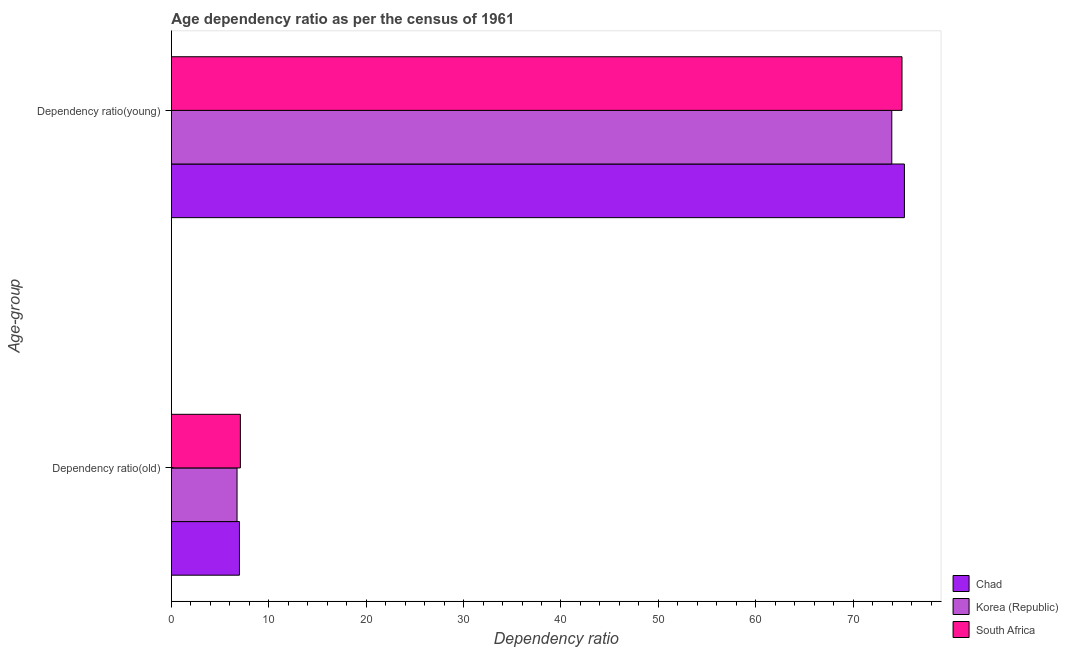Are the number of bars per tick equal to the number of legend labels?
Provide a short and direct response. Yes. How many bars are there on the 2nd tick from the top?
Make the answer very short. 3. What is the label of the 1st group of bars from the top?
Provide a succinct answer. Dependency ratio(young). What is the age dependency ratio(young) in South Africa?
Provide a short and direct response. 75.02. Across all countries, what is the maximum age dependency ratio(young)?
Provide a short and direct response. 75.27. Across all countries, what is the minimum age dependency ratio(old)?
Ensure brevity in your answer.  6.74. In which country was the age dependency ratio(young) maximum?
Offer a terse response. Chad. In which country was the age dependency ratio(old) minimum?
Give a very brief answer. Korea (Republic). What is the total age dependency ratio(young) in the graph?
Offer a very short reply. 224.25. What is the difference between the age dependency ratio(old) in South Africa and that in Korea (Republic)?
Offer a terse response. 0.34. What is the difference between the age dependency ratio(young) in South Africa and the age dependency ratio(old) in Korea (Republic)?
Provide a short and direct response. 68.27. What is the average age dependency ratio(young) per country?
Make the answer very short. 74.75. What is the difference between the age dependency ratio(young) and age dependency ratio(old) in Korea (Republic)?
Your answer should be very brief. 67.23. What is the ratio of the age dependency ratio(old) in Chad to that in South Africa?
Offer a terse response. 0.99. What does the 1st bar from the top in Dependency ratio(old) represents?
Provide a short and direct response. South Africa. What does the 3rd bar from the bottom in Dependency ratio(young) represents?
Offer a terse response. South Africa. Are all the bars in the graph horizontal?
Offer a terse response. Yes. How many countries are there in the graph?
Your answer should be very brief. 3. Are the values on the major ticks of X-axis written in scientific E-notation?
Provide a succinct answer. No. Does the graph contain grids?
Your answer should be compact. No. What is the title of the graph?
Make the answer very short. Age dependency ratio as per the census of 1961. Does "Cote d'Ivoire" appear as one of the legend labels in the graph?
Give a very brief answer. No. What is the label or title of the X-axis?
Provide a succinct answer. Dependency ratio. What is the label or title of the Y-axis?
Offer a terse response. Age-group. What is the Dependency ratio of Chad in Dependency ratio(old)?
Offer a very short reply. 6.99. What is the Dependency ratio of Korea (Republic) in Dependency ratio(old)?
Offer a terse response. 6.74. What is the Dependency ratio of South Africa in Dependency ratio(old)?
Offer a very short reply. 7.08. What is the Dependency ratio in Chad in Dependency ratio(young)?
Your answer should be compact. 75.27. What is the Dependency ratio of Korea (Republic) in Dependency ratio(young)?
Provide a succinct answer. 73.97. What is the Dependency ratio in South Africa in Dependency ratio(young)?
Your answer should be very brief. 75.02. Across all Age-group, what is the maximum Dependency ratio of Chad?
Offer a very short reply. 75.27. Across all Age-group, what is the maximum Dependency ratio in Korea (Republic)?
Provide a short and direct response. 73.97. Across all Age-group, what is the maximum Dependency ratio in South Africa?
Offer a terse response. 75.02. Across all Age-group, what is the minimum Dependency ratio of Chad?
Offer a very short reply. 6.99. Across all Age-group, what is the minimum Dependency ratio of Korea (Republic)?
Keep it short and to the point. 6.74. Across all Age-group, what is the minimum Dependency ratio of South Africa?
Your answer should be very brief. 7.08. What is the total Dependency ratio in Chad in the graph?
Offer a terse response. 82.25. What is the total Dependency ratio of Korea (Republic) in the graph?
Your response must be concise. 80.71. What is the total Dependency ratio of South Africa in the graph?
Offer a very short reply. 82.1. What is the difference between the Dependency ratio in Chad in Dependency ratio(old) and that in Dependency ratio(young)?
Give a very brief answer. -68.28. What is the difference between the Dependency ratio in Korea (Republic) in Dependency ratio(old) and that in Dependency ratio(young)?
Make the answer very short. -67.23. What is the difference between the Dependency ratio of South Africa in Dependency ratio(old) and that in Dependency ratio(young)?
Your response must be concise. -67.93. What is the difference between the Dependency ratio in Chad in Dependency ratio(old) and the Dependency ratio in Korea (Republic) in Dependency ratio(young)?
Your answer should be compact. -66.98. What is the difference between the Dependency ratio of Chad in Dependency ratio(old) and the Dependency ratio of South Africa in Dependency ratio(young)?
Your answer should be very brief. -68.03. What is the difference between the Dependency ratio of Korea (Republic) in Dependency ratio(old) and the Dependency ratio of South Africa in Dependency ratio(young)?
Make the answer very short. -68.27. What is the average Dependency ratio in Chad per Age-group?
Your response must be concise. 41.13. What is the average Dependency ratio of Korea (Republic) per Age-group?
Provide a succinct answer. 40.36. What is the average Dependency ratio in South Africa per Age-group?
Keep it short and to the point. 41.05. What is the difference between the Dependency ratio of Chad and Dependency ratio of Korea (Republic) in Dependency ratio(old)?
Offer a very short reply. 0.24. What is the difference between the Dependency ratio in Chad and Dependency ratio in South Africa in Dependency ratio(old)?
Your answer should be very brief. -0.1. What is the difference between the Dependency ratio in Korea (Republic) and Dependency ratio in South Africa in Dependency ratio(old)?
Provide a short and direct response. -0.34. What is the difference between the Dependency ratio of Chad and Dependency ratio of Korea (Republic) in Dependency ratio(young)?
Provide a short and direct response. 1.3. What is the difference between the Dependency ratio of Chad and Dependency ratio of South Africa in Dependency ratio(young)?
Ensure brevity in your answer.  0.25. What is the difference between the Dependency ratio of Korea (Republic) and Dependency ratio of South Africa in Dependency ratio(young)?
Give a very brief answer. -1.05. What is the ratio of the Dependency ratio of Chad in Dependency ratio(old) to that in Dependency ratio(young)?
Provide a succinct answer. 0.09. What is the ratio of the Dependency ratio of Korea (Republic) in Dependency ratio(old) to that in Dependency ratio(young)?
Provide a short and direct response. 0.09. What is the ratio of the Dependency ratio in South Africa in Dependency ratio(old) to that in Dependency ratio(young)?
Ensure brevity in your answer.  0.09. What is the difference between the highest and the second highest Dependency ratio of Chad?
Make the answer very short. 68.28. What is the difference between the highest and the second highest Dependency ratio in Korea (Republic)?
Make the answer very short. 67.23. What is the difference between the highest and the second highest Dependency ratio in South Africa?
Offer a very short reply. 67.93. What is the difference between the highest and the lowest Dependency ratio of Chad?
Your response must be concise. 68.28. What is the difference between the highest and the lowest Dependency ratio of Korea (Republic)?
Your response must be concise. 67.23. What is the difference between the highest and the lowest Dependency ratio in South Africa?
Provide a short and direct response. 67.93. 